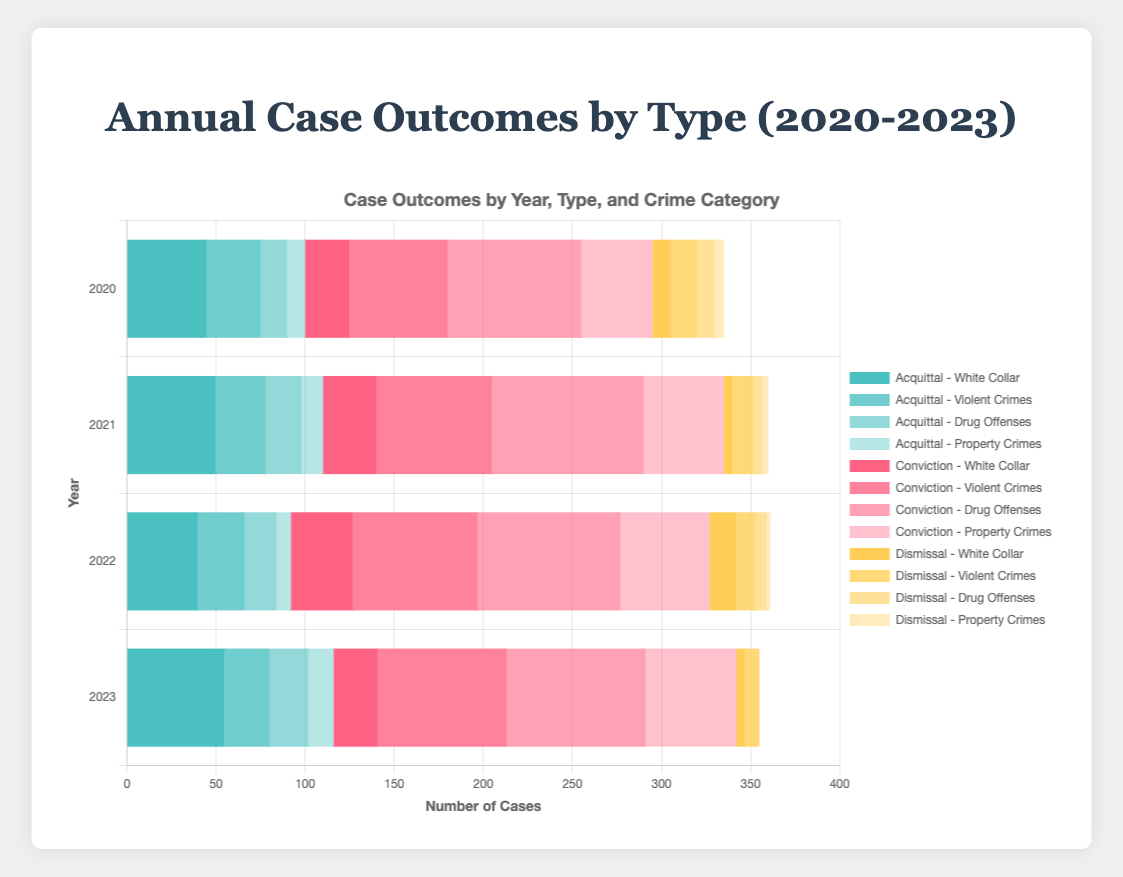What trend can be observed in acquittal cases for White Collar crimes from 2020 to 2023? Looking at the horizontal stacked bars for the acquittal cases in the White Collar category from 2020 to 2023, the numbers are 45, 50, 40, and 55 respectively. Analyzing these figures, there is an increase from 2020 to 2021, a drop in 2022, and a subsequent rise again in 2023.
Answer: Increasing overall Between 2020 and 2023, which year had the highest number of convictions for Drug Offenses and by how much compared to the next highest year? The convictions for Drug Offenses are 75 in 2020, 85 in 2021, 80 in 2022, and 78 in 2023. The highest number was in 2021 with 85 convictions. The next highest was 80 in 2022. Therefore, 2021 had 5 more convictions compared to the next highest year, 2022.
Answer: 2021, 5 more How does the total count of convictions for Property Crimes in 2022 compare to the total of acquittals and dismissals for Property Crimes in the same year? In 2022, the convictions for Property Crimes are 50. The acquittals are 8, and the dismissals are 2. Summing the acquittals and dismissals gives 8 + 2 = 10. Comparing this to convictions (50), convictions are much higher.
Answer: Convictions are 50; Acquittals and Dismissals combined are 10 What is the pattern of dismissals for Drug Offenses from 2020 to 2023? The numbers of dismissals for Drug Offenses over the years are 10 (2020), 5 (2021), 6 (2022), and 0 (2023). This data reveals a decreasing pattern with a slight increase in 2022, but dropping to zero in 2023.
Answer: Decreasing with slight increase in 2022 Compare the total number of Violent Crimes acquitted to total Violent Crimes convicted between 2020 and 2023. Aggregating the data:
- Acquittals: 30 (2020), 28 (2021), 26 (2022), 25 (2023) = 109 
- Convictions: 55 (2020), 65 (2021), 70 (2022), 72 (2023) = 262
 
Comparing these totals, there are significantly more convictions (262) than acquittals (109) for Violent Crimes across these years.
Answer: Convictions are higher: 262 vs. 109 How did the number of acquittals for Drug Offenses change from 2020 to 2023, and what might this indicate? The number of acquittals for Drug Offenses over the years are 15 (2020), 20 (2021), 18 (2022), and 22 (2023). This shows an overall increasing trend with a slight dip in 2022. This might indicate improving defense strategies or weaker prosecutions in more recent years.
Answer: Generally increasing 